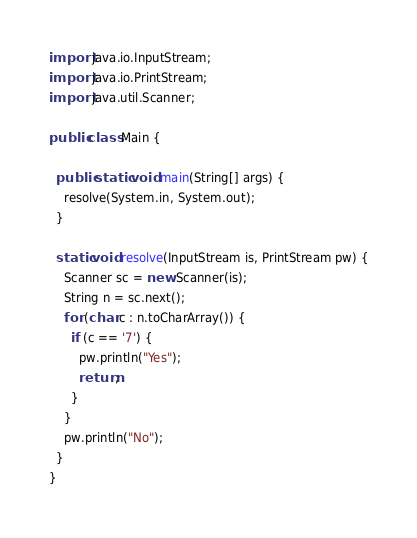Convert code to text. <code><loc_0><loc_0><loc_500><loc_500><_Java_>import java.io.InputStream;
import java.io.PrintStream;
import java.util.Scanner;

public class Main {

  public static void main(String[] args) {
    resolve(System.in, System.out);
  }

  static void resolve(InputStream is, PrintStream pw) {
    Scanner sc = new Scanner(is);
    String n = sc.next();
    for (char c : n.toCharArray()) {
      if (c == '7') {
        pw.println("Yes");
        return;
      }
    }
    pw.println("No");
  }
}
</code> 